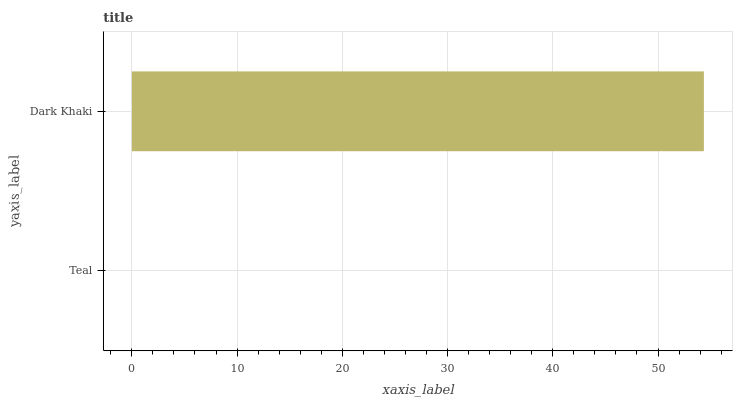Is Teal the minimum?
Answer yes or no. Yes. Is Dark Khaki the maximum?
Answer yes or no. Yes. Is Dark Khaki the minimum?
Answer yes or no. No. Is Dark Khaki greater than Teal?
Answer yes or no. Yes. Is Teal less than Dark Khaki?
Answer yes or no. Yes. Is Teal greater than Dark Khaki?
Answer yes or no. No. Is Dark Khaki less than Teal?
Answer yes or no. No. Is Dark Khaki the high median?
Answer yes or no. Yes. Is Teal the low median?
Answer yes or no. Yes. Is Teal the high median?
Answer yes or no. No. Is Dark Khaki the low median?
Answer yes or no. No. 